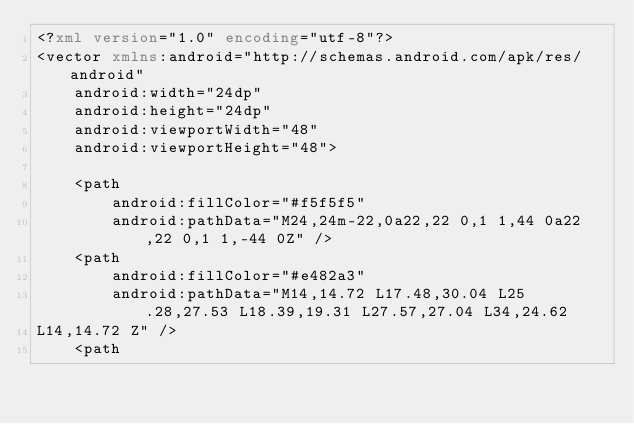<code> <loc_0><loc_0><loc_500><loc_500><_XML_><?xml version="1.0" encoding="utf-8"?>
<vector xmlns:android="http://schemas.android.com/apk/res/android"
    android:width="24dp"
    android:height="24dp"
    android:viewportWidth="48"
    android:viewportHeight="48">

    <path
        android:fillColor="#f5f5f5"
        android:pathData="M24,24m-22,0a22,22 0,1 1,44 0a22,22 0,1 1,-44 0Z" />
    <path
        android:fillColor="#e482a3"
        android:pathData="M14,14.72 L17.48,30.04 L25.28,27.53 L18.39,19.31 L27.57,27.04 L34,24.62
L14,14.72 Z" />
    <path</code> 